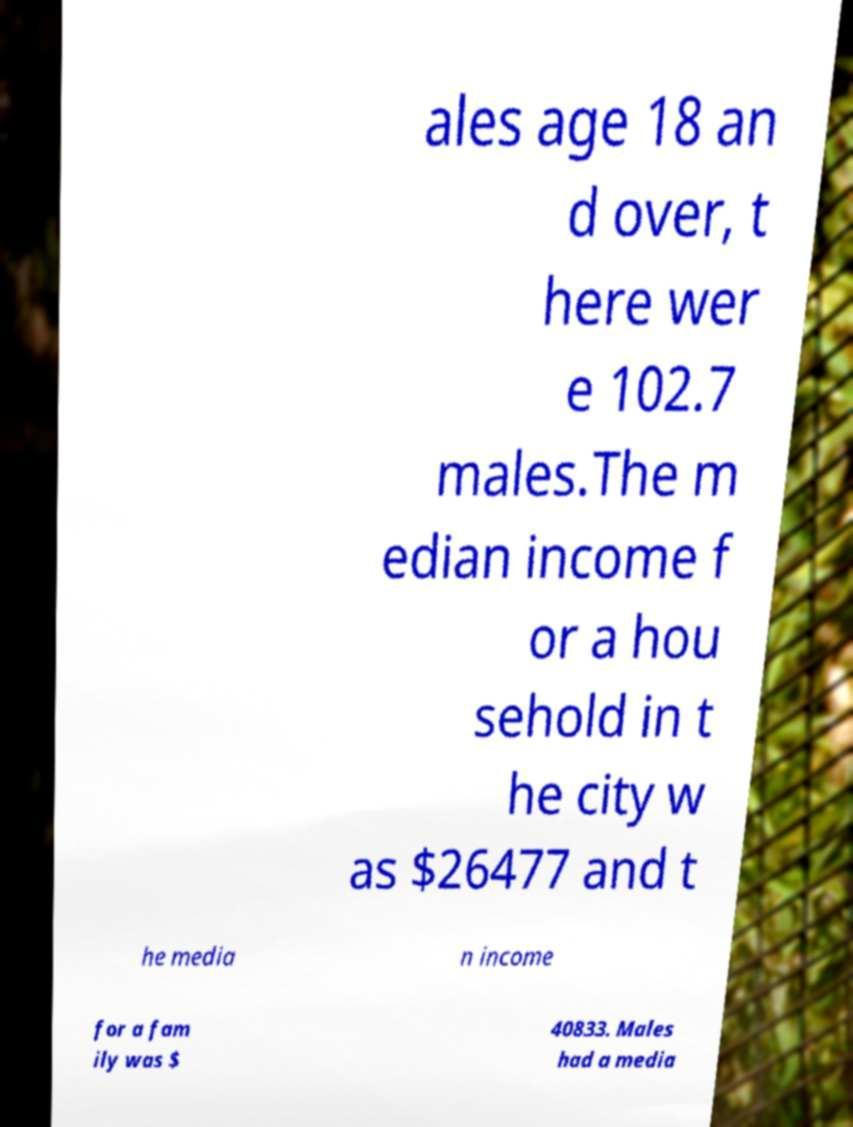What messages or text are displayed in this image? I need them in a readable, typed format. ales age 18 an d over, t here wer e 102.7 males.The m edian income f or a hou sehold in t he city w as $26477 and t he media n income for a fam ily was $ 40833. Males had a media 